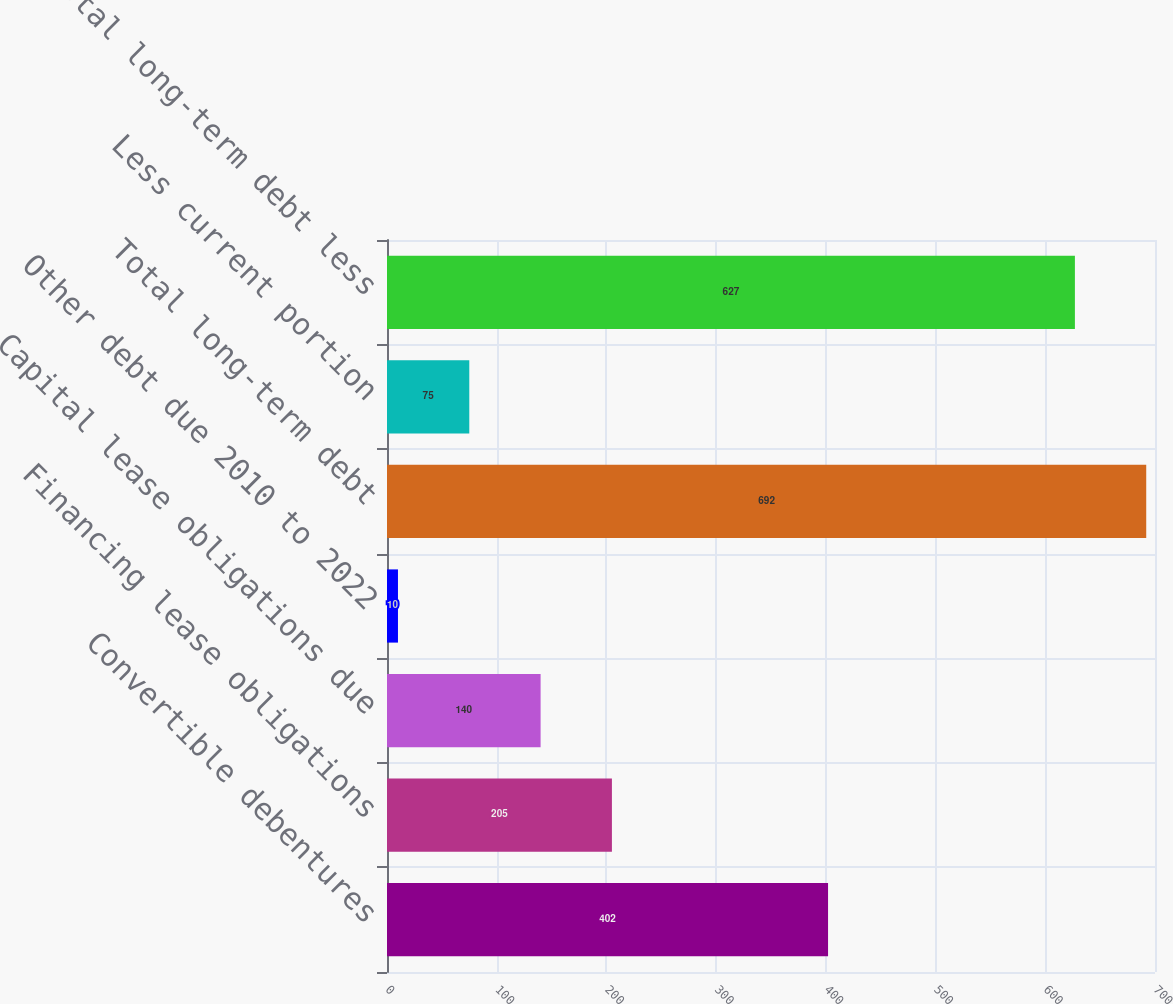Convert chart. <chart><loc_0><loc_0><loc_500><loc_500><bar_chart><fcel>Convertible debentures<fcel>Financing lease obligations<fcel>Capital lease obligations due<fcel>Other debt due 2010 to 2022<fcel>Total long-term debt<fcel>Less current portion<fcel>Total long-term debt less<nl><fcel>402<fcel>205<fcel>140<fcel>10<fcel>692<fcel>75<fcel>627<nl></chart> 